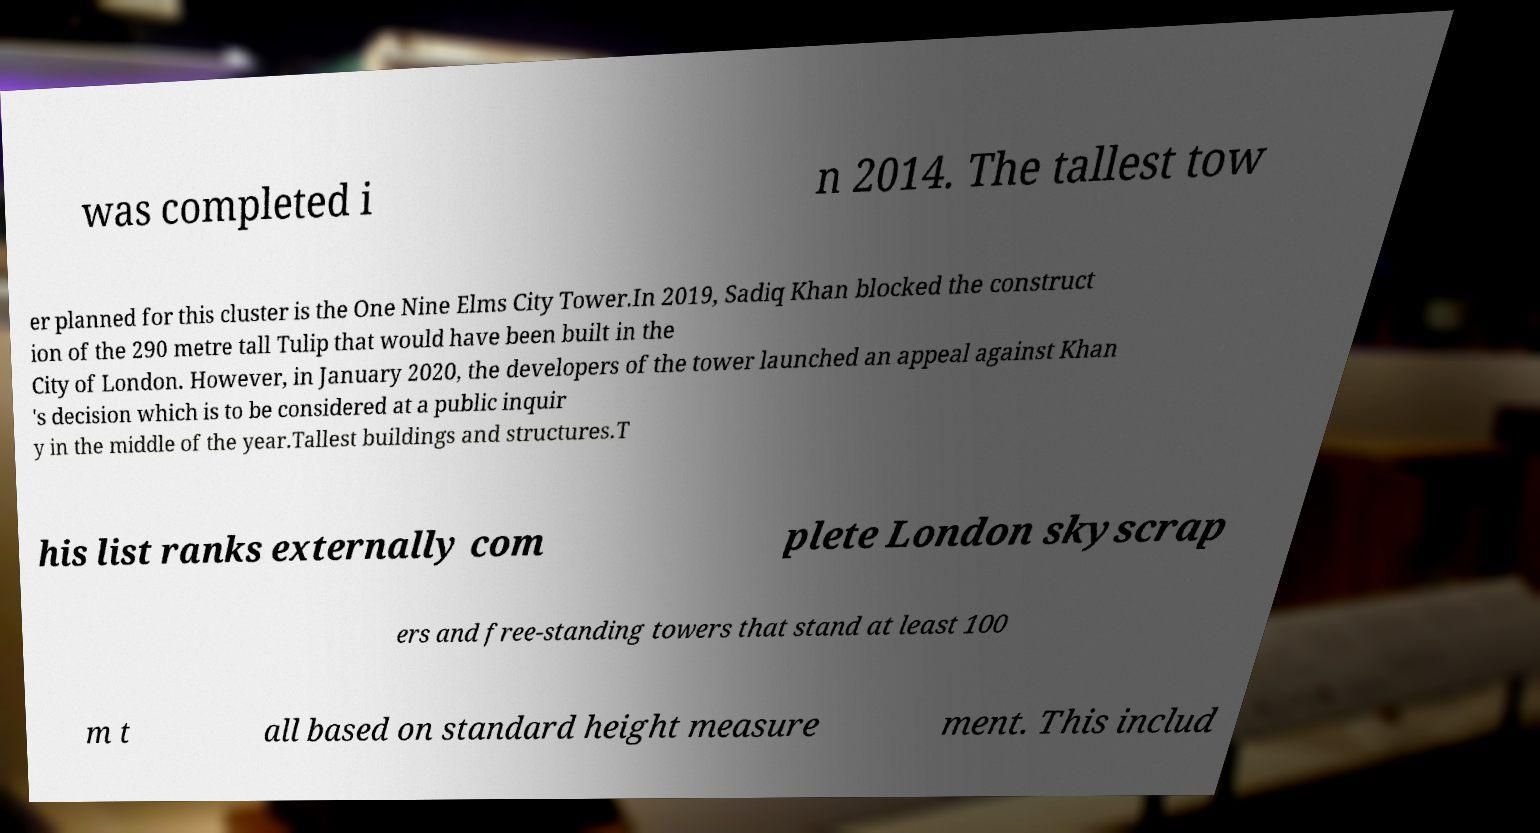For documentation purposes, I need the text within this image transcribed. Could you provide that? was completed i n 2014. The tallest tow er planned for this cluster is the One Nine Elms City Tower.In 2019, Sadiq Khan blocked the construct ion of the 290 metre tall Tulip that would have been built in the City of London. However, in January 2020, the developers of the tower launched an appeal against Khan 's decision which is to be considered at a public inquir y in the middle of the year.Tallest buildings and structures.T his list ranks externally com plete London skyscrap ers and free-standing towers that stand at least 100 m t all based on standard height measure ment. This includ 